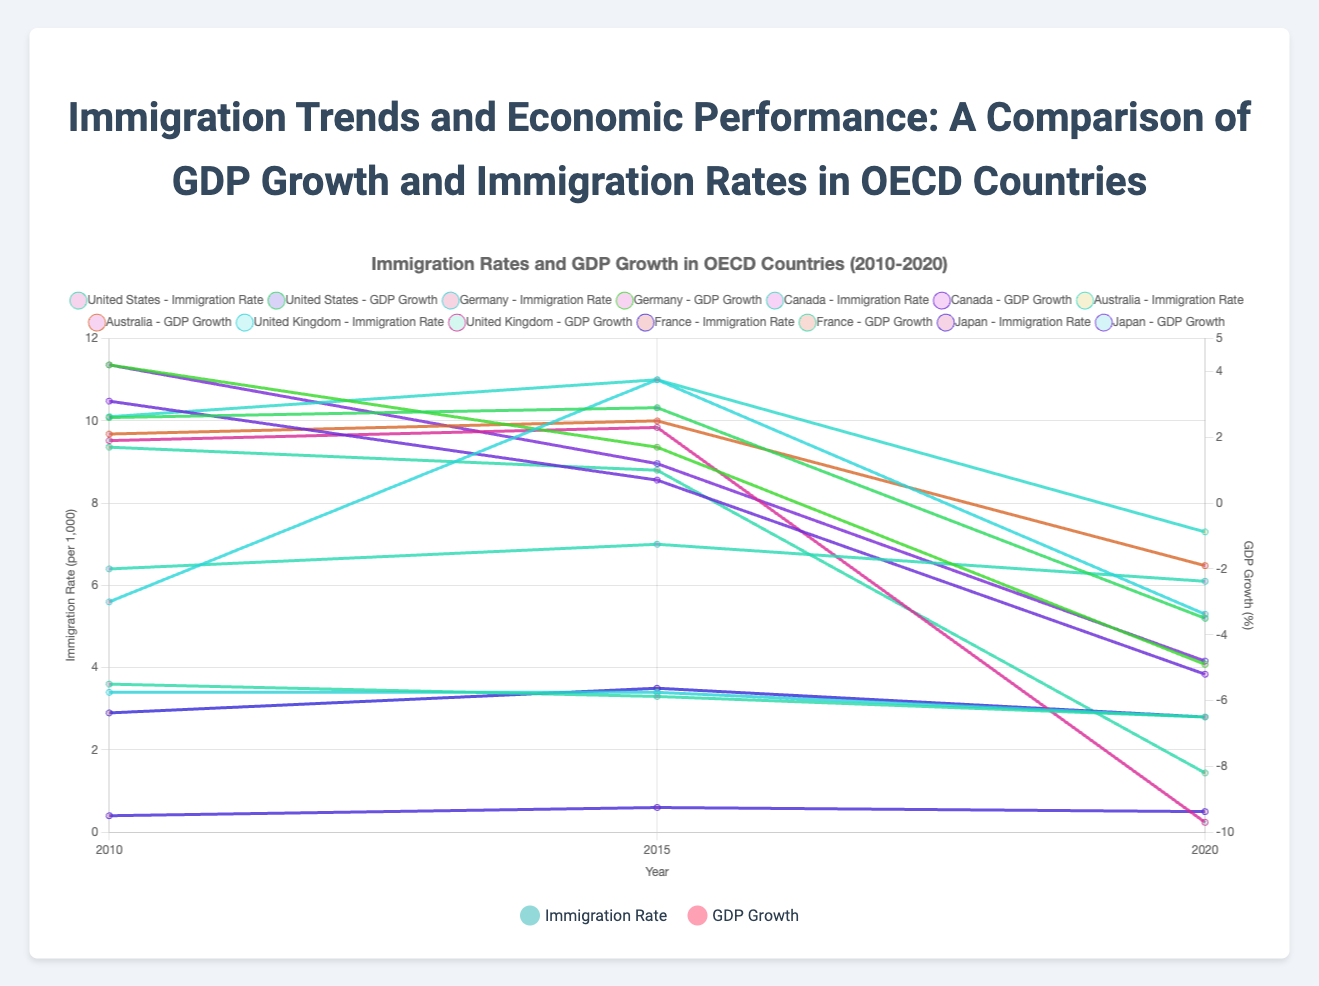What is the overall trend of immigration rates in the United States from 2010 to 2020? The graph shows that the immigration rates in the United States have slightly decreased from 3.6 per 1,000 in 2010 to 2.8 per 1,000 in 2020. Observing the line representing the United States' immigration rate, we notice a downward trend.
Answer: Decreasing Compare the GDP growth rates of Germany and Japan in 2010. Which country had a higher GDP growth rate? In 2010, Germany had a GDP growth rate of 4.2%, while Japan also had a GDP growth rate of 4.2%. Referring to the figure, the heights of the GDP growth bars for both countries in 2010 are equivalent.
Answer: Both had equal GDP growth rates Between 2015 and 2020, which country experienced a larger decrease in immigration rate, Germany or Australia? Germany's immigration rate dropped from 11.0 per 1,000 in 2015 to 5.3 per 1,000 in 2020, a decrease of 5.7 per 1,000. Australia's immigration rate decreased from 11.0 per 1,000 in 2015 to 7.3 per 1,000 in 2020, a decrease of 3.7 per 1,000. Comparing the drops, Germany experienced a larger decrease.
Answer: Germany Calculate the average GDP growth rate for Canada over the years 2010, 2015, and 2020. The GDP growth rates for Canada are 3.1% (2010), 0.7% (2015), and -5.2% (2020). Summing these values gives (3.1 + 0.7 - 5.2) = -1.4. The average GDP growth rate is calculated by dividing the sum by the number of years, resulting in -1.4/3 ≈ -0.47%.
Answer: -0.47% Which country had the highest immigration rate in 2020? Observing the 2020 data for immigration rates, Australia had the highest immigration rate of 7.3 per 1,000 compared to other countries listed. This is determined by visually comparing the heights of the immigration rate lines for each country in 2020.
Answer: Australia How did the GDP growth rate for the United Kingdom change from 2010 to 2015? The GDP growth rate for the United Kingdom in 2010 was 1.9%, and in 2015 it was 2.3%. By subtracting the 2010 rate from the 2015 rate (2.3 - 1.9), the GDP growth rate increased by 0.4% over this period.
Answer: Increased by 0.4% Identify the country with the highest GDP growth rate in 2010. In 2010, both Germany and Japan had the highest GDP growth rates of 4.2%, as denoted by the tallest bars in the GDP growth category for that year.
Answer: Germany and Japan 